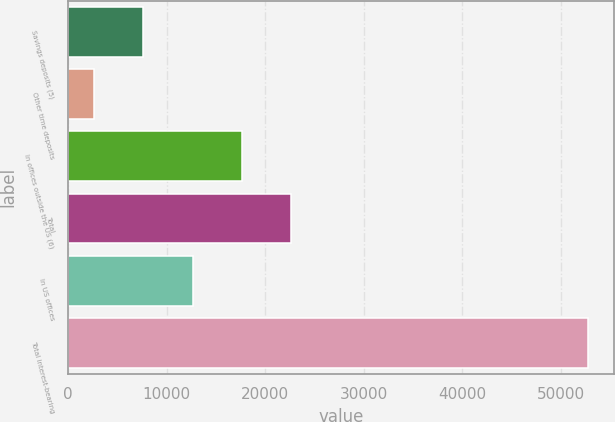<chart> <loc_0><loc_0><loc_500><loc_500><bar_chart><fcel>Savings deposits (5)<fcel>Other time deposits<fcel>In offices outside the US (6)<fcel>Total<fcel>In US offices<fcel>Total interest-bearing<nl><fcel>7618.6<fcel>2604<fcel>17647.8<fcel>22662.4<fcel>12633.2<fcel>52750<nl></chart> 